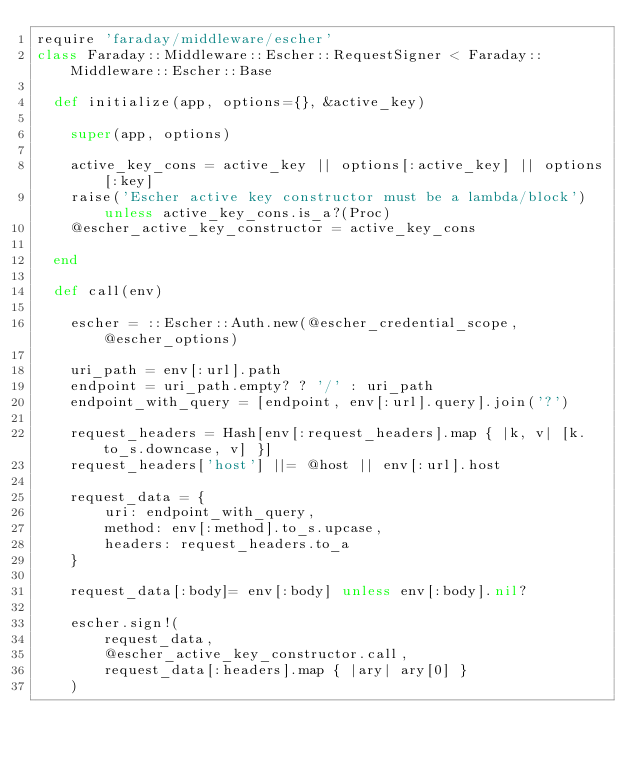Convert code to text. <code><loc_0><loc_0><loc_500><loc_500><_Ruby_>require 'faraday/middleware/escher'
class Faraday::Middleware::Escher::RequestSigner < Faraday::Middleware::Escher::Base

  def initialize(app, options={}, &active_key)

    super(app, options)

    active_key_cons = active_key || options[:active_key] || options[:key]
    raise('Escher active key constructor must be a lambda/block') unless active_key_cons.is_a?(Proc)
    @escher_active_key_constructor = active_key_cons

  end

  def call(env)

    escher = ::Escher::Auth.new(@escher_credential_scope, @escher_options)

    uri_path = env[:url].path
    endpoint = uri_path.empty? ? '/' : uri_path
    endpoint_with_query = [endpoint, env[:url].query].join('?')

    request_headers = Hash[env[:request_headers].map { |k, v| [k.to_s.downcase, v] }]
    request_headers['host'] ||= @host || env[:url].host

    request_data = {
        uri: endpoint_with_query,
        method: env[:method].to_s.upcase,
        headers: request_headers.to_a
    }

    request_data[:body]= env[:body] unless env[:body].nil?

    escher.sign!(
        request_data,
        @escher_active_key_constructor.call,
        request_data[:headers].map { |ary| ary[0] }
    )
</code> 